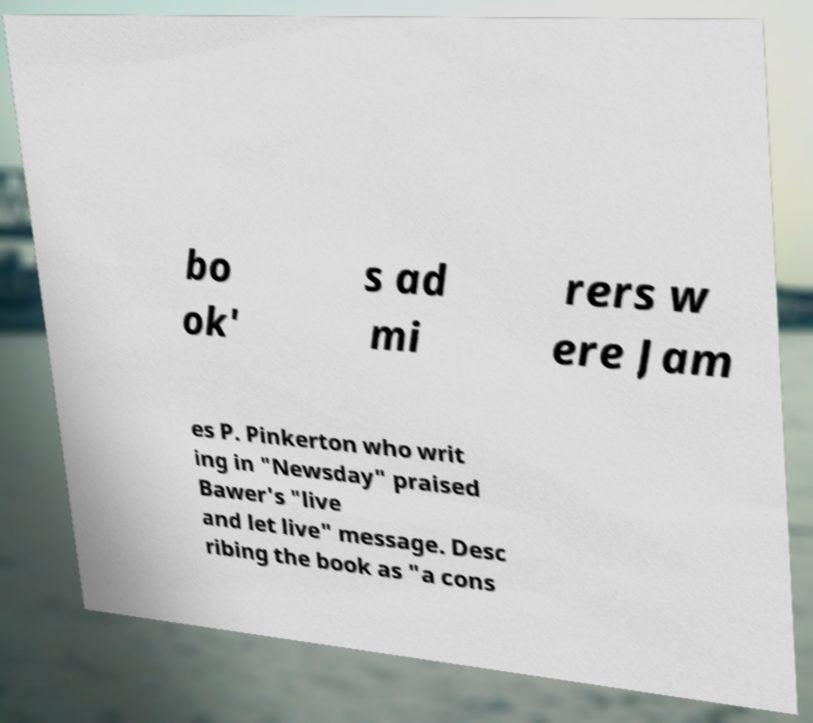Please identify and transcribe the text found in this image. bo ok' s ad mi rers w ere Jam es P. Pinkerton who writ ing in "Newsday" praised Bawer's "live and let live" message. Desc ribing the book as "a cons 